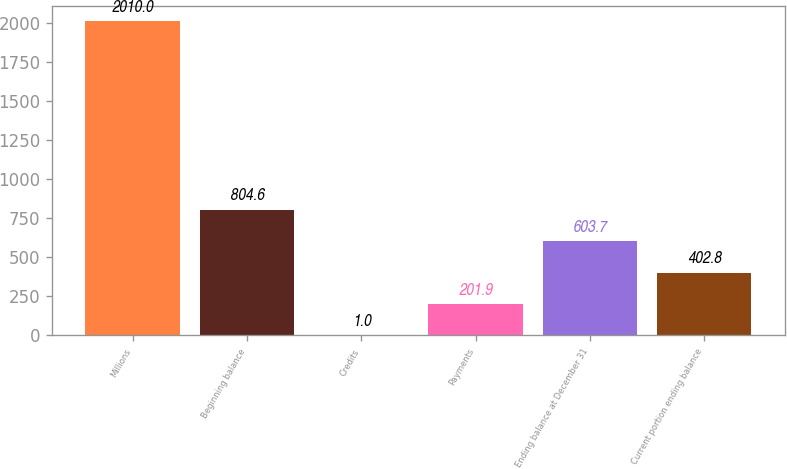Convert chart. <chart><loc_0><loc_0><loc_500><loc_500><bar_chart><fcel>Millions<fcel>Beginning balance<fcel>Credits<fcel>Payments<fcel>Ending balance at December 31<fcel>Current portion ending balance<nl><fcel>2010<fcel>804.6<fcel>1<fcel>201.9<fcel>603.7<fcel>402.8<nl></chart> 